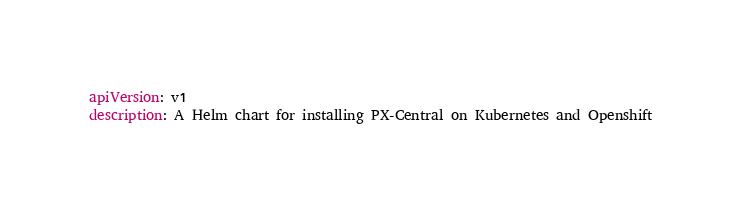Convert code to text. <code><loc_0><loc_0><loc_500><loc_500><_YAML_>apiVersion: v1
description: A Helm chart for installing PX-Central on Kubernetes and Openshift</code> 